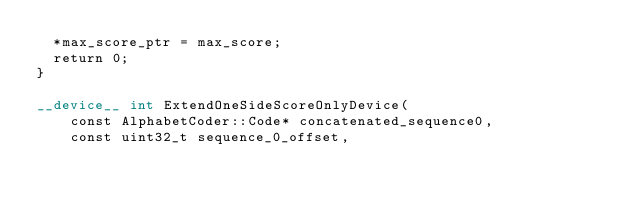<code> <loc_0><loc_0><loc_500><loc_500><_Cuda_>	*max_score_ptr = max_score;
	return 0;
}

__device__ int ExtendOneSideScoreOnlyDevice(
		const AlphabetCoder::Code* concatenated_sequence0,
		const uint32_t sequence_0_offset,</code> 